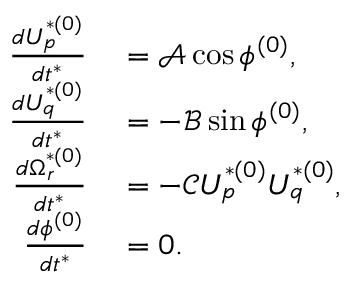Convert formula to latex. <formula><loc_0><loc_0><loc_500><loc_500>\begin{array} { r l } { \frac { d U _ { p } ^ { * ( 0 ) } } { d t ^ { * } } } & = \mathcal { A } \cos \phi ^ { ( 0 ) } , } \\ { \frac { d U _ { q } ^ { * ( 0 ) } } { d t ^ { * } } } & = - \mathcal { B } \sin \phi ^ { ( 0 ) } , } \\ { \frac { d \Omega _ { r } ^ { * ( 0 ) } } { d t ^ { * } } } & = - \mathcal { C } U _ { p } ^ { * ( 0 ) } U _ { q } ^ { * ( 0 ) } , } \\ { \frac { d \phi ^ { ( 0 ) } } { d t ^ { * } } } & = 0 . } \end{array}</formula> 